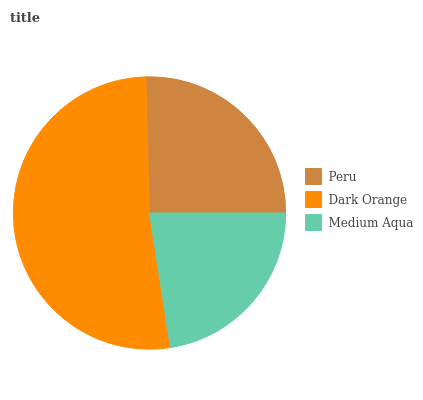Is Medium Aqua the minimum?
Answer yes or no. Yes. Is Dark Orange the maximum?
Answer yes or no. Yes. Is Dark Orange the minimum?
Answer yes or no. No. Is Medium Aqua the maximum?
Answer yes or no. No. Is Dark Orange greater than Medium Aqua?
Answer yes or no. Yes. Is Medium Aqua less than Dark Orange?
Answer yes or no. Yes. Is Medium Aqua greater than Dark Orange?
Answer yes or no. No. Is Dark Orange less than Medium Aqua?
Answer yes or no. No. Is Peru the high median?
Answer yes or no. Yes. Is Peru the low median?
Answer yes or no. Yes. Is Dark Orange the high median?
Answer yes or no. No. Is Dark Orange the low median?
Answer yes or no. No. 